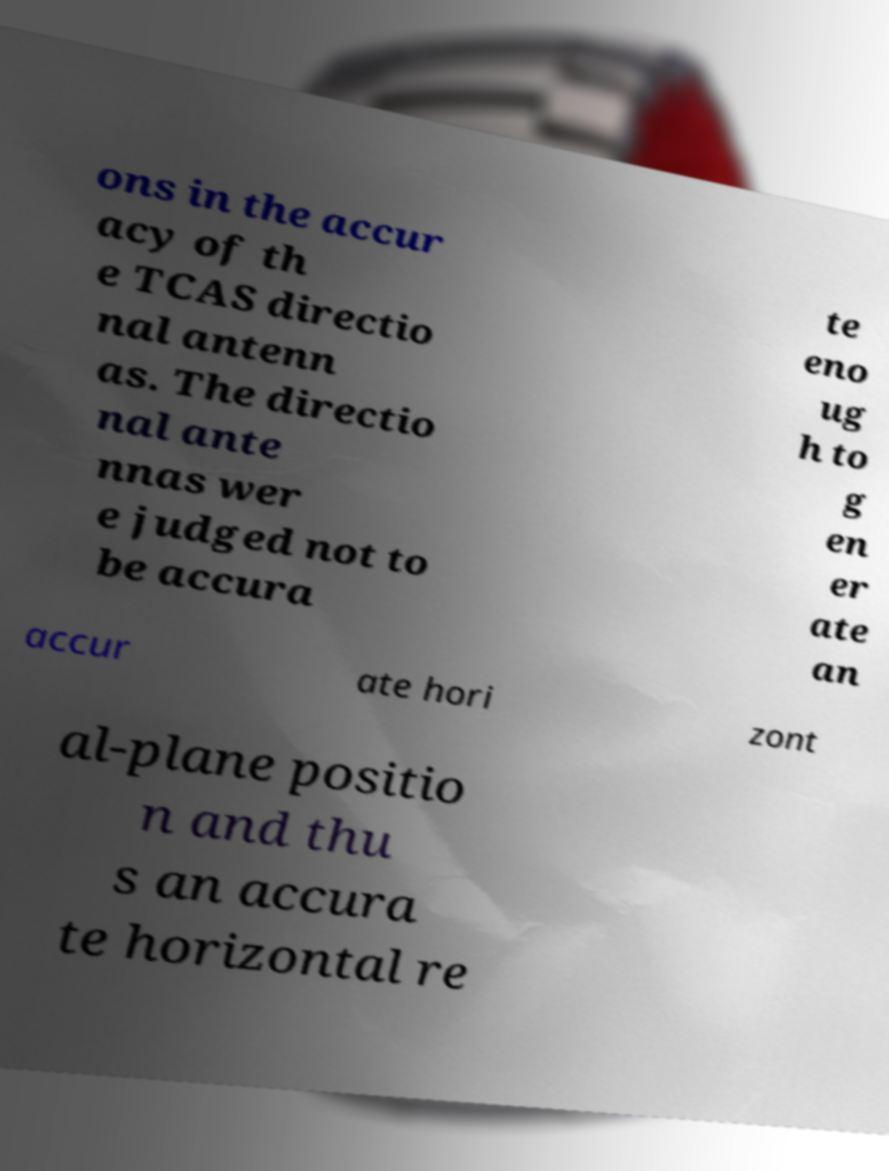What messages or text are displayed in this image? I need them in a readable, typed format. ons in the accur acy of th e TCAS directio nal antenn as. The directio nal ante nnas wer e judged not to be accura te eno ug h to g en er ate an accur ate hori zont al-plane positio n and thu s an accura te horizontal re 